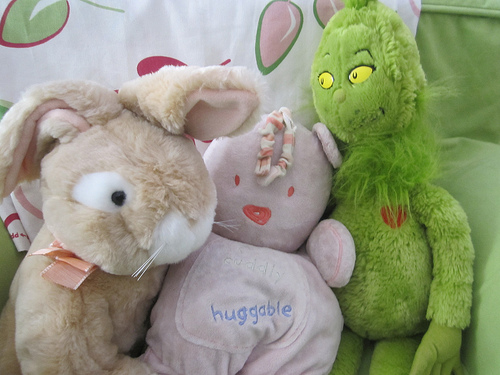<image>
Is the grinch behind the rabbit? No. The grinch is not behind the rabbit. From this viewpoint, the grinch appears to be positioned elsewhere in the scene. Is the pink doll to the right of the green doll? No. The pink doll is not to the right of the green doll. The horizontal positioning shows a different relationship. 